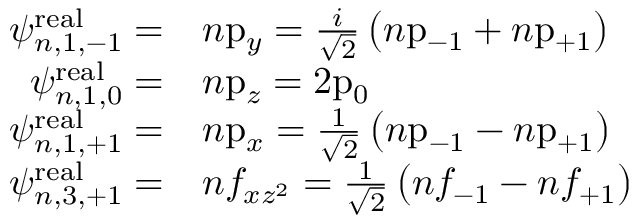Convert formula to latex. <formula><loc_0><loc_0><loc_500><loc_500>{ \begin{array} { r l } { \psi _ { n , 1 , - 1 } ^ { r e a l } = } & { n { p } _ { y } = { \frac { i } { \sqrt { 2 } } } \left ( n { p } _ { - 1 } + n { p } _ { + 1 } \right ) } \\ { \psi _ { n , 1 , 0 } ^ { r e a l } = } & { n { p } _ { z } = 2 { p } _ { 0 } } \\ { \psi _ { n , 1 , + 1 } ^ { r e a l } = } & { n { p } _ { x } = { \frac { 1 } { \sqrt { 2 } } } \left ( n { p } _ { - 1 } - n { p } _ { + 1 } \right ) } \\ { \psi _ { n , 3 , + 1 } ^ { r e a l } = } & { n f _ { x z ^ { 2 } } = { \frac { 1 } { \sqrt { 2 } } } \left ( n f _ { - 1 } - n f _ { + 1 } \right ) } \end{array} }</formula> 